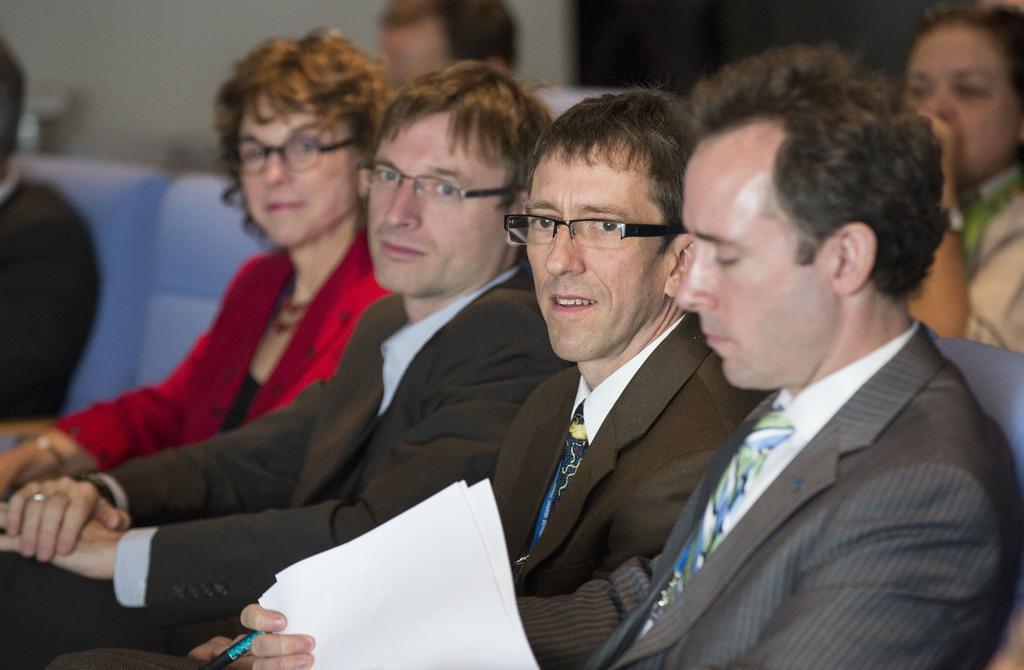Could you give a brief overview of what you see in this image? In this image we can see people sitting. The person sitting on the right is holding papers and a pen. In the background there is a wall. 